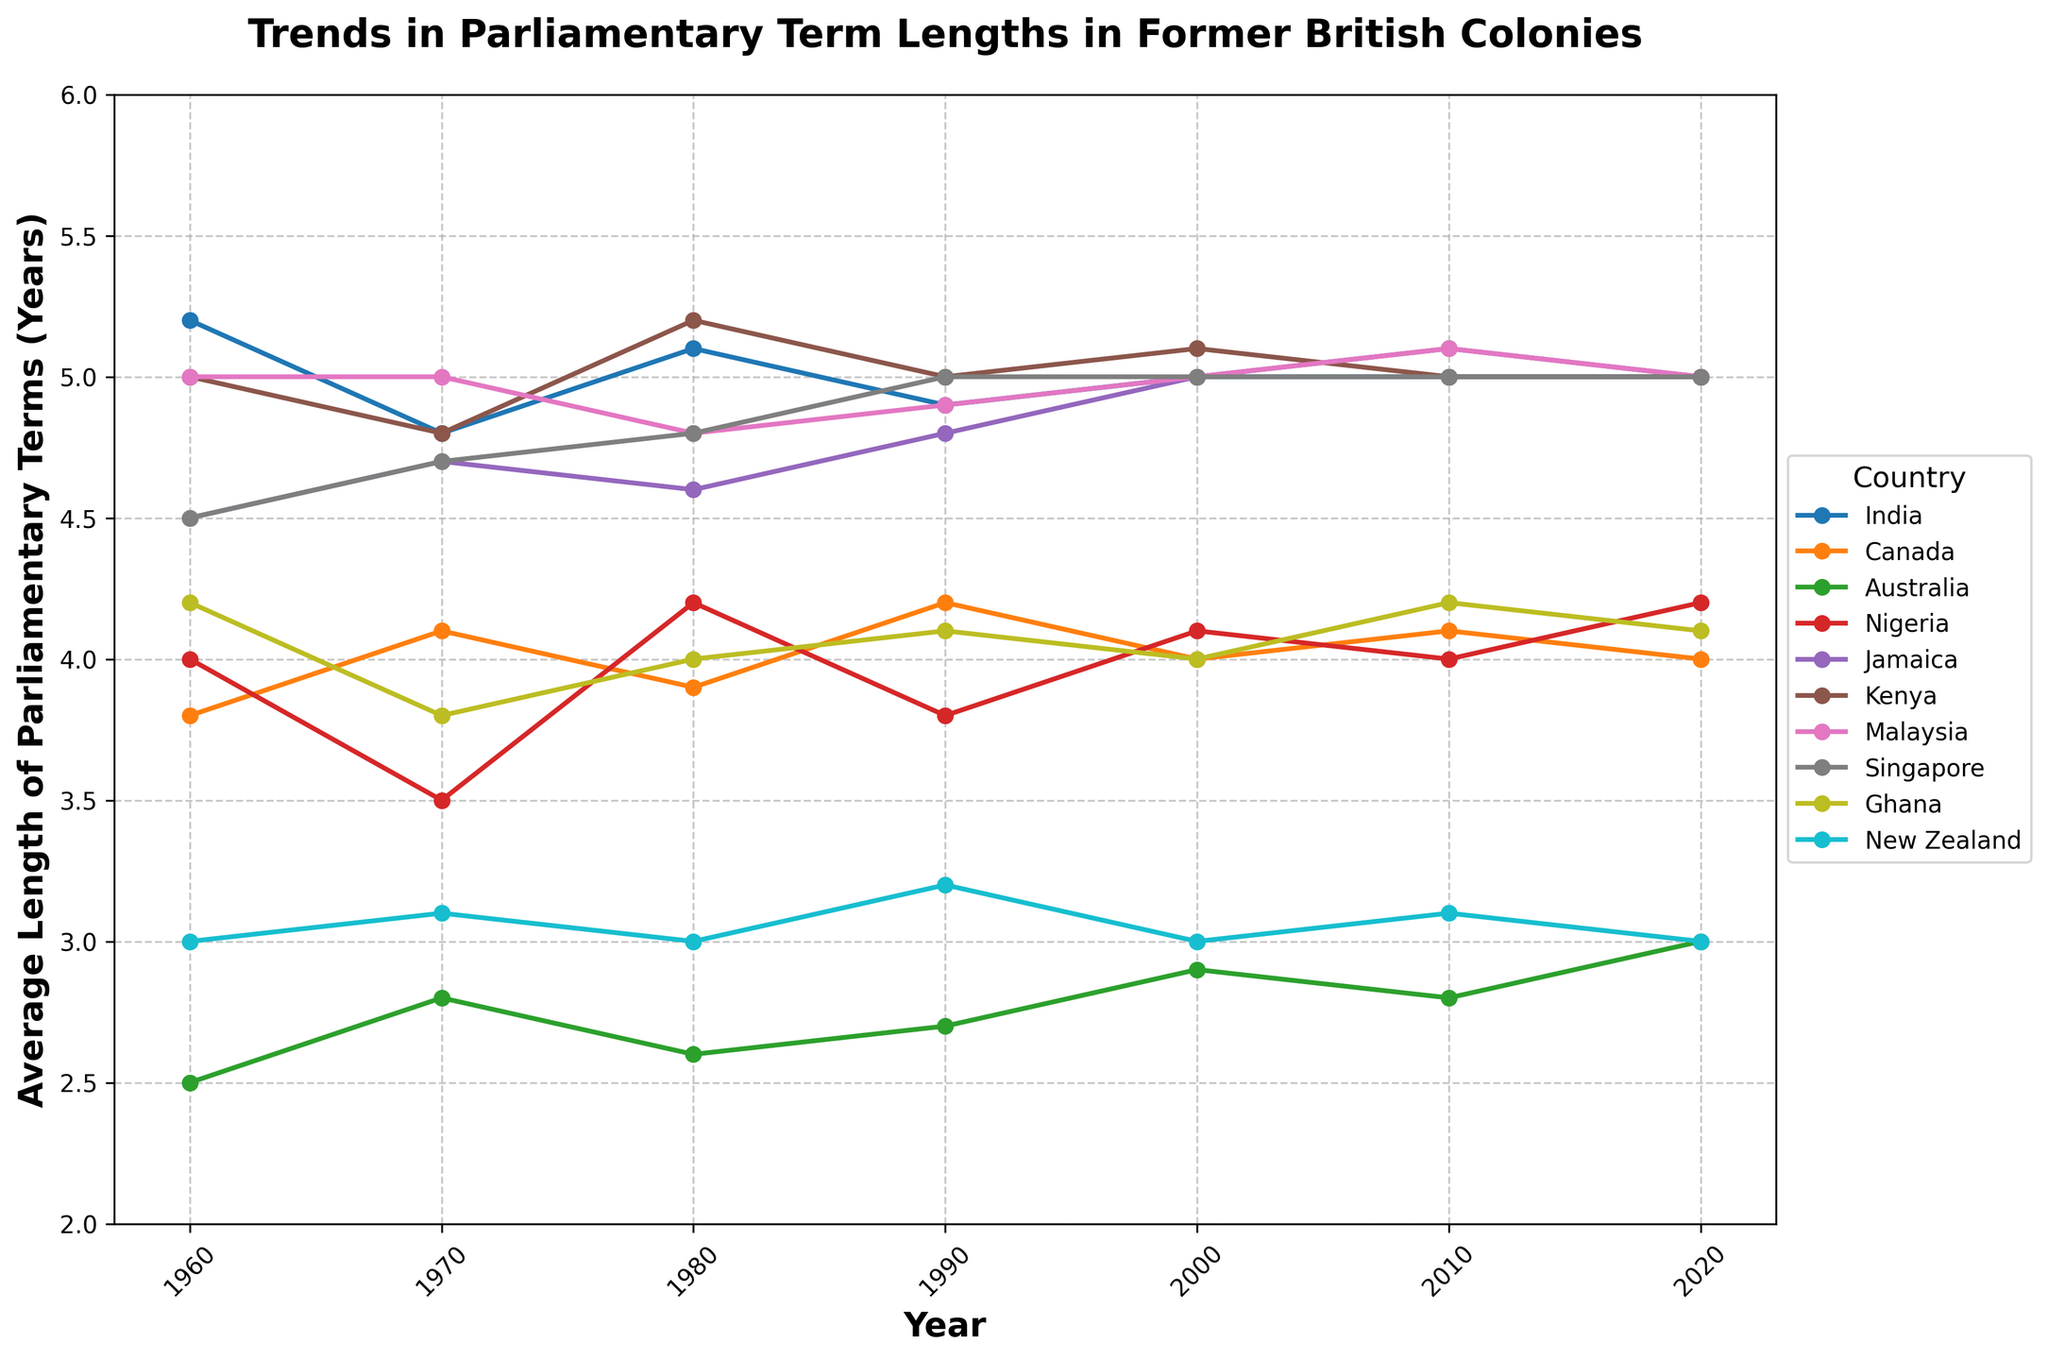What was the trend in the average length of parliamentary terms in India from 1960 to 2020? To determine the trend, examine the line corresponding to India. It starts at 5.2 years in 1960, decreases to 4.8 years in 1970, then fluctuates between 4.9 and 5.1 years until stabilizing at 5.0 years from 2000 to 2020.
Answer: The trend is relatively stable, with minor fluctuations around 5.0 years Which country had the highest average length of parliamentary terms in the year 2020? Look at the y-values for each country in the year 2020. India, Jamaica, Kenya, Malaysia, and Singapore all reached 5.0 years. Note that some values might be very close, so picking out these is necessary.
Answer: India, Jamaica, Kenya, Malaysia, and Singapore (5.0 years) Compare the average length of parliamentary terms for Canada and Australia in 1980. Which was higher? Locate the year 1980 on the x-axis and compare the y-values associated with Canada and Australia. Canada is at 3.9 years, while Australia is at 2.6 years.
Answer: Canada (3.9 years) What is the difference in average parliamentary term length between Nigeria and Ghana in 1990? Look at the values for both countries in 1990. Nigeria is at 3.8 years and Ghana is at 4.1 years. Calculate the difference as 4.1 - 3.8 = 0.3 years.
Answer: 0.3 years Which country showed a consistent increase in the length of parliamentary terms from 1960 to 2020? Scan the lines for each country for consistent upward trends. Jamaica shows an increase from 4.5 years in 1960 to 5.0 years in 2020.
Answer: Jamaica How did the average length of parliamentary terms in Malaysia change from 2000 to 2010? Look at the values for Malaysia in 2000 and 2010. The values are 5.0 years in 2000 and 5.1 years in 2010.
Answer: It increased by 0.1 years Which countries had their highest recorded average length of parliamentary terms in the 1970s? Examine each country's line for peaks during the 1970s. India and Kenya both reached 4.8 years in 1970, and Nigeria recorded 3.5 years.
Answer: None What was the average length of parliamentary terms for New Zealand in 1990 compared to 2020? Identify the values for New Zealand in 1990 and 2020. In 1990, it is 3.2 years; in 2020, it is 3.0 years.
Answer: 3.2 years in 1990 and 3.0 years in 2020 Which country had the most fluctuations in the average length of parliamentary terms over the observed period? Visually inspect each line for variability. Australia's line fluctuates more than the others, ranging from 2.5 years to 3.0 years.
Answer: Australia 